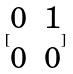Convert formula to latex. <formula><loc_0><loc_0><loc_500><loc_500>[ \begin{matrix} 0 & 1 \\ 0 & 0 \end{matrix} ]</formula> 